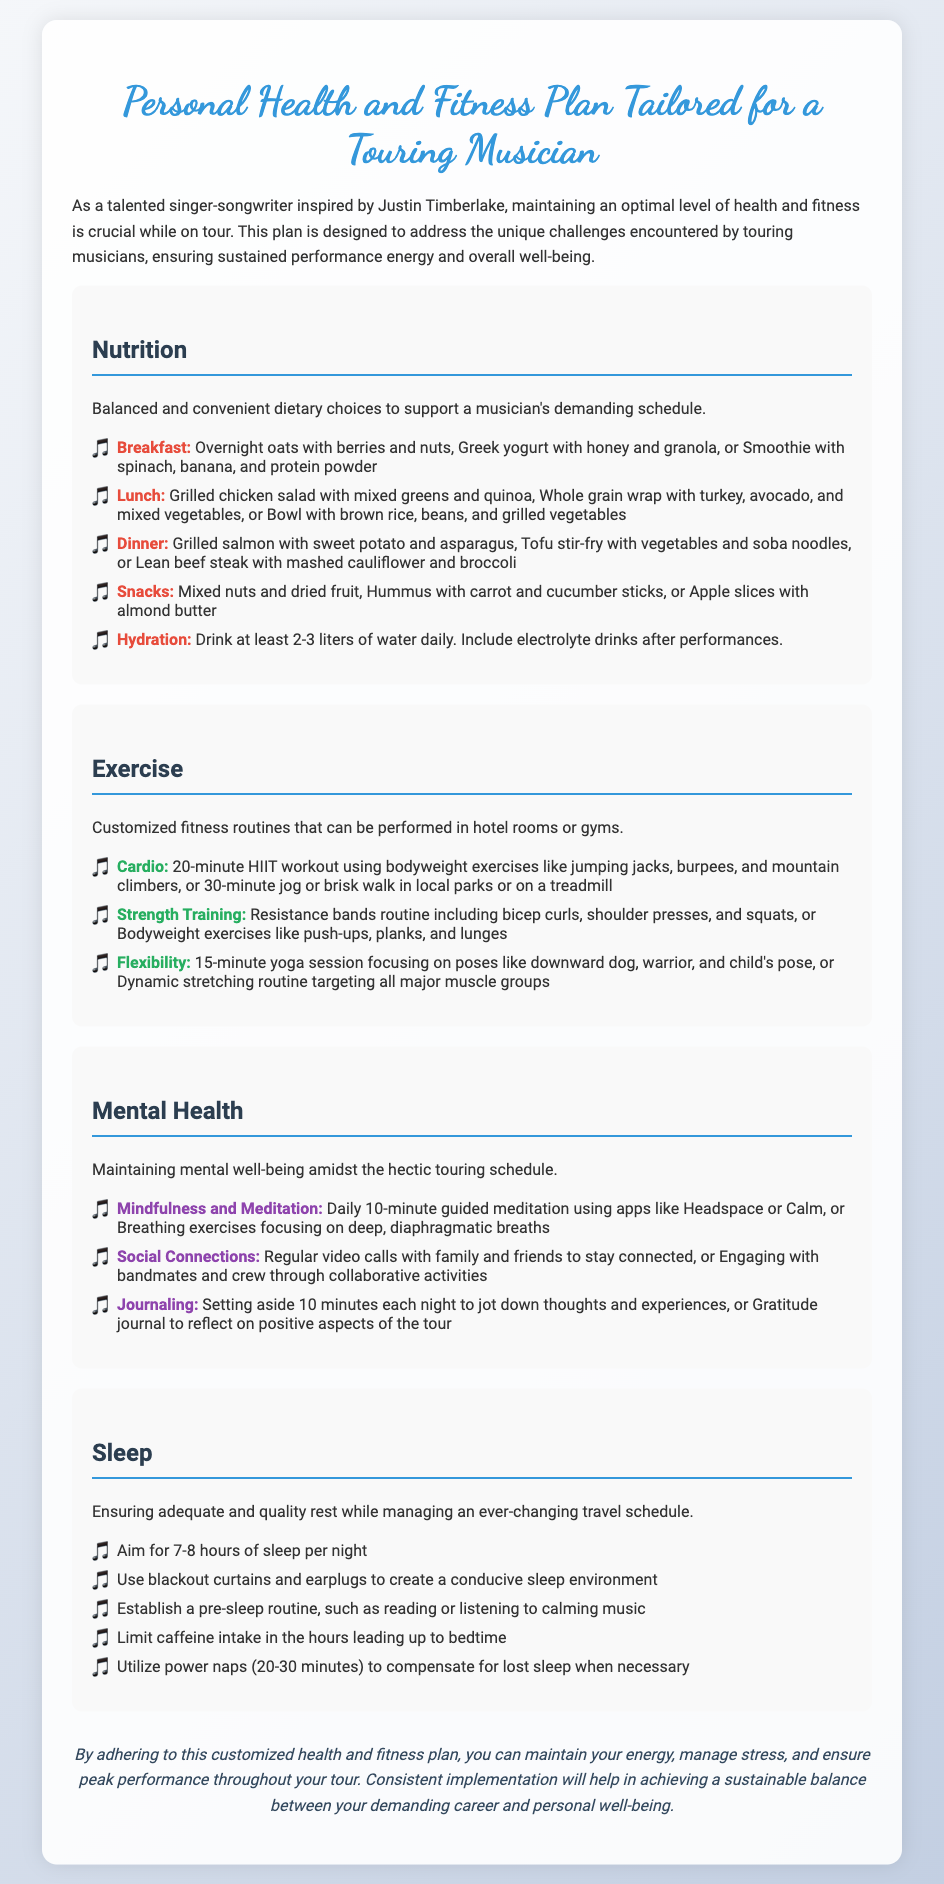What is the title of the document? The title of the document is stated prominently at the top of the rendered page.
Answer: Personal Health and Fitness Plan Tailored for a Touring Musician How many hours of sleep should a touring musician aim for? The document specifies the recommended amount of sleep for musicians in the sleep section.
Answer: 7-8 hours What is one example of a breakfast option mentioned? The breakfast options are listed in the nutrition section, providing several examples.
Answer: Overnight oats with berries and nuts Which strategy is suggested for mental health? The mental health section outlines various strategies for maintaining well-being during tours.
Answer: Mindfulness and Meditation What type of workout can be done using bodyweight exercises? The exercise section specifies different types of workouts, including those that rely on bodyweight.
Answer: 20-minute HIIT workout What should a musician's daily water intake be? The hydration recommendation is provided in the nutrition section as a guideline for fluid intake.
Answer: 2-3 liters Which meal includes grilled chicken according to the plan? The document lists meals under the nutrition section; one meal specifically mentions grilled chicken.
Answer: Lunch What helps create a conducive sleep environment? The sleep section lists several suggestions for improving sleep quality.
Answer: Blackout curtains and earplugs 